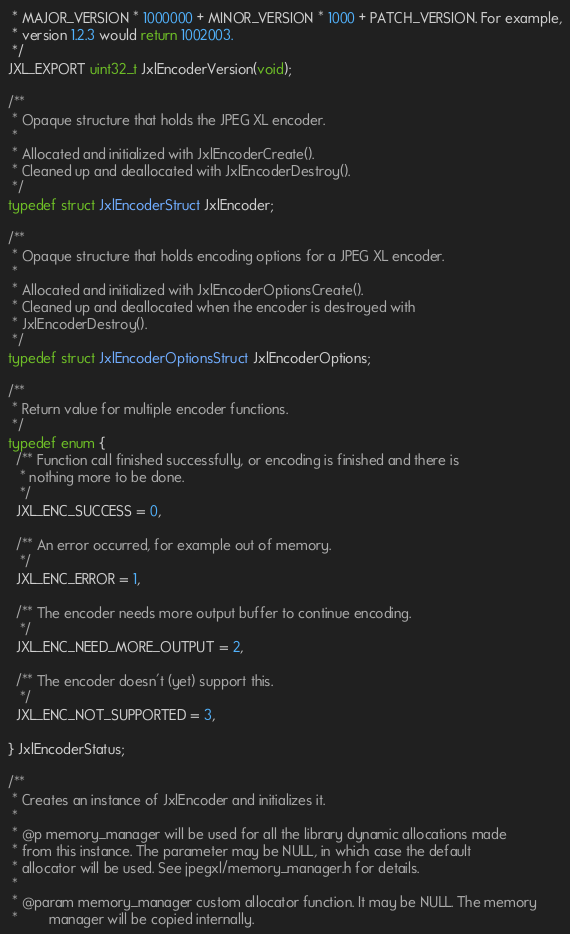Convert code to text. <code><loc_0><loc_0><loc_500><loc_500><_C_> * MAJOR_VERSION * 1000000 + MINOR_VERSION * 1000 + PATCH_VERSION. For example,
 * version 1.2.3 would return 1002003.
 */
JXL_EXPORT uint32_t JxlEncoderVersion(void);

/**
 * Opaque structure that holds the JPEG XL encoder.
 *
 * Allocated and initialized with JxlEncoderCreate().
 * Cleaned up and deallocated with JxlEncoderDestroy().
 */
typedef struct JxlEncoderStruct JxlEncoder;

/**
 * Opaque structure that holds encoding options for a JPEG XL encoder.
 *
 * Allocated and initialized with JxlEncoderOptionsCreate().
 * Cleaned up and deallocated when the encoder is destroyed with
 * JxlEncoderDestroy().
 */
typedef struct JxlEncoderOptionsStruct JxlEncoderOptions;

/**
 * Return value for multiple encoder functions.
 */
typedef enum {
  /** Function call finished successfully, or encoding is finished and there is
   * nothing more to be done.
   */
  JXL_ENC_SUCCESS = 0,

  /** An error occurred, for example out of memory.
   */
  JXL_ENC_ERROR = 1,

  /** The encoder needs more output buffer to continue encoding.
   */
  JXL_ENC_NEED_MORE_OUTPUT = 2,

  /** The encoder doesn't (yet) support this.
   */
  JXL_ENC_NOT_SUPPORTED = 3,

} JxlEncoderStatus;

/**
 * Creates an instance of JxlEncoder and initializes it.
 *
 * @p memory_manager will be used for all the library dynamic allocations made
 * from this instance. The parameter may be NULL, in which case the default
 * allocator will be used. See jpegxl/memory_manager.h for details.
 *
 * @param memory_manager custom allocator function. It may be NULL. The memory
 *        manager will be copied internally.</code> 